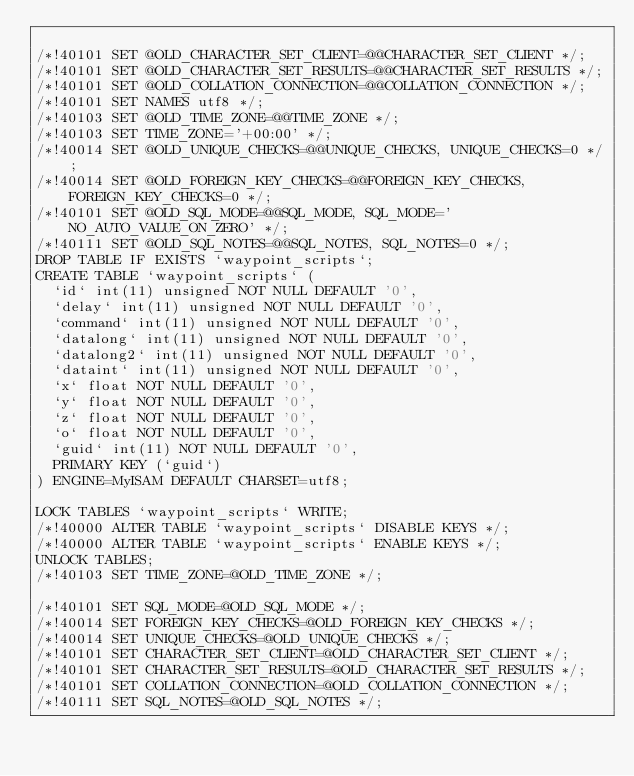Convert code to text. <code><loc_0><loc_0><loc_500><loc_500><_SQL_>
/*!40101 SET @OLD_CHARACTER_SET_CLIENT=@@CHARACTER_SET_CLIENT */;
/*!40101 SET @OLD_CHARACTER_SET_RESULTS=@@CHARACTER_SET_RESULTS */;
/*!40101 SET @OLD_COLLATION_CONNECTION=@@COLLATION_CONNECTION */;
/*!40101 SET NAMES utf8 */;
/*!40103 SET @OLD_TIME_ZONE=@@TIME_ZONE */;
/*!40103 SET TIME_ZONE='+00:00' */;
/*!40014 SET @OLD_UNIQUE_CHECKS=@@UNIQUE_CHECKS, UNIQUE_CHECKS=0 */;
/*!40014 SET @OLD_FOREIGN_KEY_CHECKS=@@FOREIGN_KEY_CHECKS, FOREIGN_KEY_CHECKS=0 */;
/*!40101 SET @OLD_SQL_MODE=@@SQL_MODE, SQL_MODE='NO_AUTO_VALUE_ON_ZERO' */;
/*!40111 SET @OLD_SQL_NOTES=@@SQL_NOTES, SQL_NOTES=0 */;
DROP TABLE IF EXISTS `waypoint_scripts`;
CREATE TABLE `waypoint_scripts` (
  `id` int(11) unsigned NOT NULL DEFAULT '0',
  `delay` int(11) unsigned NOT NULL DEFAULT '0',
  `command` int(11) unsigned NOT NULL DEFAULT '0',
  `datalong` int(11) unsigned NOT NULL DEFAULT '0',
  `datalong2` int(11) unsigned NOT NULL DEFAULT '0',
  `dataint` int(11) unsigned NOT NULL DEFAULT '0',
  `x` float NOT NULL DEFAULT '0',
  `y` float NOT NULL DEFAULT '0',
  `z` float NOT NULL DEFAULT '0',
  `o` float NOT NULL DEFAULT '0',
  `guid` int(11) NOT NULL DEFAULT '0',
  PRIMARY KEY (`guid`)
) ENGINE=MyISAM DEFAULT CHARSET=utf8;

LOCK TABLES `waypoint_scripts` WRITE;
/*!40000 ALTER TABLE `waypoint_scripts` DISABLE KEYS */;
/*!40000 ALTER TABLE `waypoint_scripts` ENABLE KEYS */;
UNLOCK TABLES;
/*!40103 SET TIME_ZONE=@OLD_TIME_ZONE */;

/*!40101 SET SQL_MODE=@OLD_SQL_MODE */;
/*!40014 SET FOREIGN_KEY_CHECKS=@OLD_FOREIGN_KEY_CHECKS */;
/*!40014 SET UNIQUE_CHECKS=@OLD_UNIQUE_CHECKS */;
/*!40101 SET CHARACTER_SET_CLIENT=@OLD_CHARACTER_SET_CLIENT */;
/*!40101 SET CHARACTER_SET_RESULTS=@OLD_CHARACTER_SET_RESULTS */;
/*!40101 SET COLLATION_CONNECTION=@OLD_COLLATION_CONNECTION */;
/*!40111 SET SQL_NOTES=@OLD_SQL_NOTES */;

</code> 